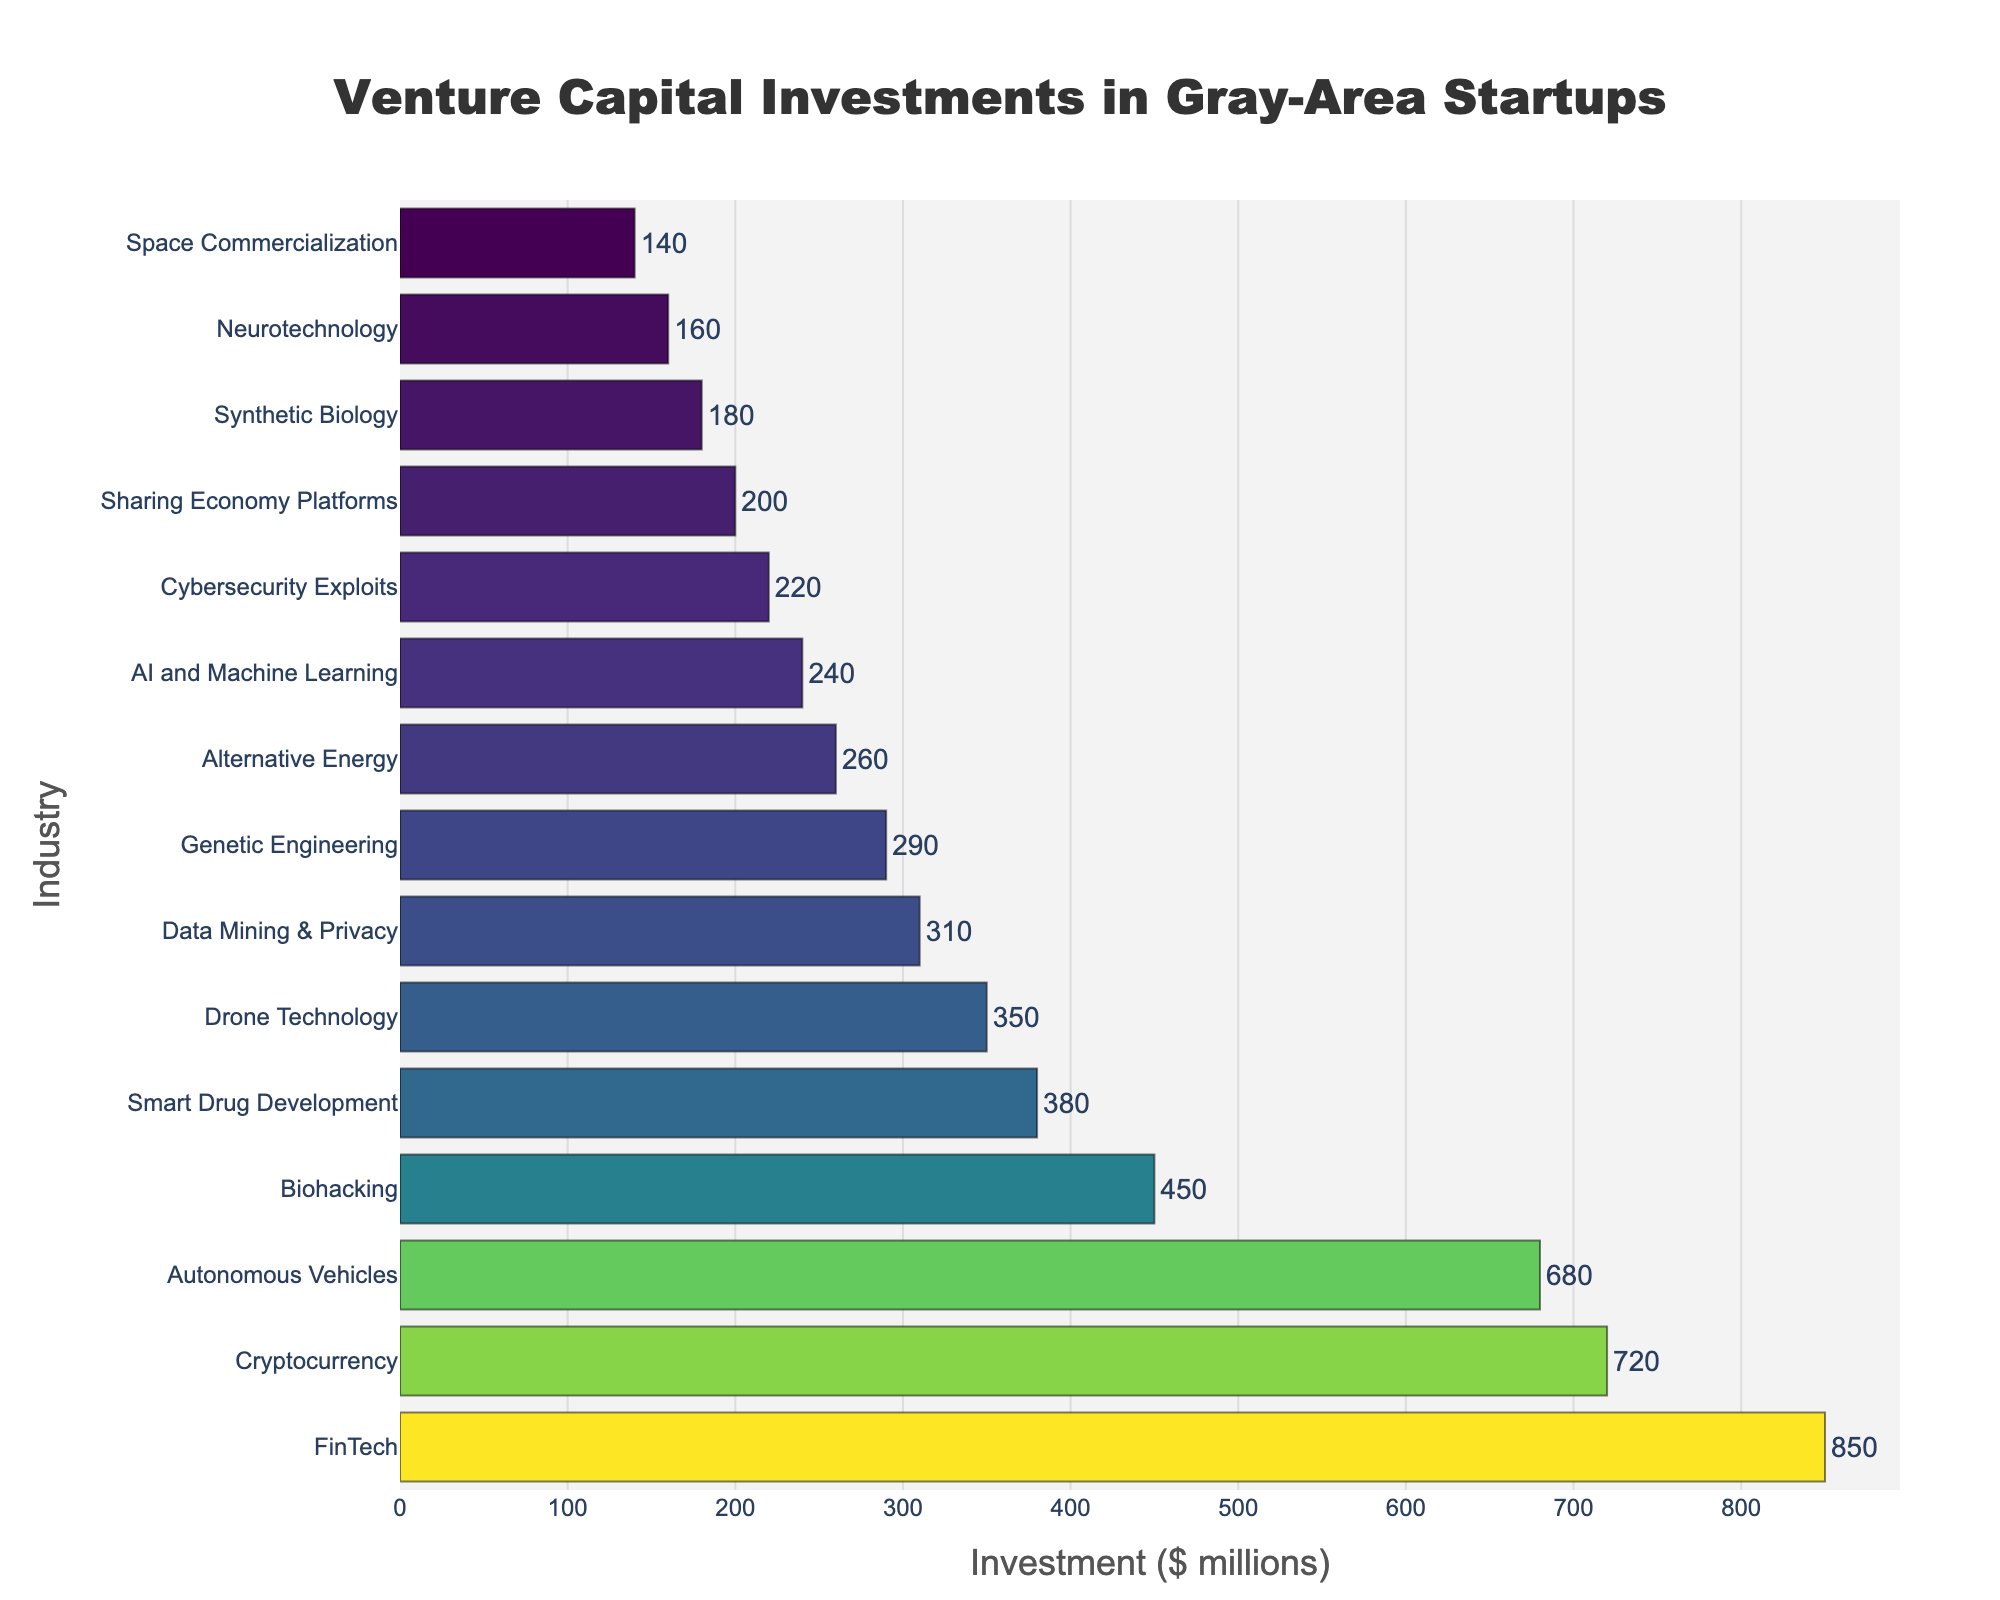What is the industry with the highest venture capital investment? By observing the horizontal bars on the figure, the industry with the longest bar represents the highest investment. The longest bar is for FinTech, indicating it has the highest investment.
Answer: FinTech Which industry has the least venture capital investment? By looking at the figure, the shortest bar corresponds to the industry with the least venture capital investment. The shortest bar is for Space Commercialization, indicating it has the least investment.
Answer: Space Commercialization How much more venture capital investment does FinTech have compared to Space Commercialization? Identify the values for both FinTech and Space Commercialization from the figure. FinTech has $850 million, and Space Commercialization has $140 million. Subtract the smaller value from the larger value: $850M - $140M = $710M.
Answer: $710 million Which industries have venture capital investments greater than $500 million? By examining the figure, locate the bars that extend past the $500 million mark. The industries with investments greater than $500 million are FinTech, Cryptocurrency, and Autonomous Vehicles.
Answer: FinTech, Cryptocurrency, Autonomous Vehicles What is the combined venture capital investment for Biohacking and Genetic Engineering? Find the investment values for Biohacking and Genetic Engineering in the figure. Biohacking has $450 million, and Genetic Engineering has $290 million. Add these values: $450M + $290M = $740M.
Answer: $740 million Compare the venture capital investment in AI and Machine Learning with that in Cybersecurity Exploits. Which one is higher and by how much? Identify the investment values for both AI and Machine Learning and Cybersecurity Exploits from the figure. AI and Machine Learning has $240 million, and Cybersecurity Exploits has $220 million. Since $240M > $220M, subtract the smaller value from the larger value: $240M - $220M = $20M.
Answer: AI and Machine Learning; $20 million What is the median venture capital investment among all the industries listed in the chart? First, list all investments in ascending order: $140M, $160M, $180M, $200M, $220M, $240M, $260M, $290M, $310M, $350M, $380M, $450M, $680M, $720M, $850M. The median is the middle value in this ordered list. Since there are 15 data points, the median is the 8th value, which is $290M.
Answer: $290 million 